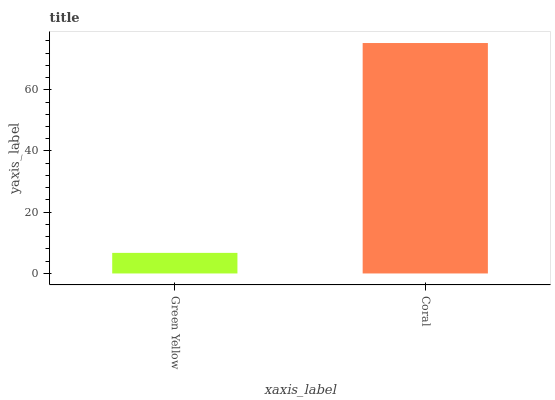Is Coral the minimum?
Answer yes or no. No. Is Coral greater than Green Yellow?
Answer yes or no. Yes. Is Green Yellow less than Coral?
Answer yes or no. Yes. Is Green Yellow greater than Coral?
Answer yes or no. No. Is Coral less than Green Yellow?
Answer yes or no. No. Is Coral the high median?
Answer yes or no. Yes. Is Green Yellow the low median?
Answer yes or no. Yes. Is Green Yellow the high median?
Answer yes or no. No. Is Coral the low median?
Answer yes or no. No. 